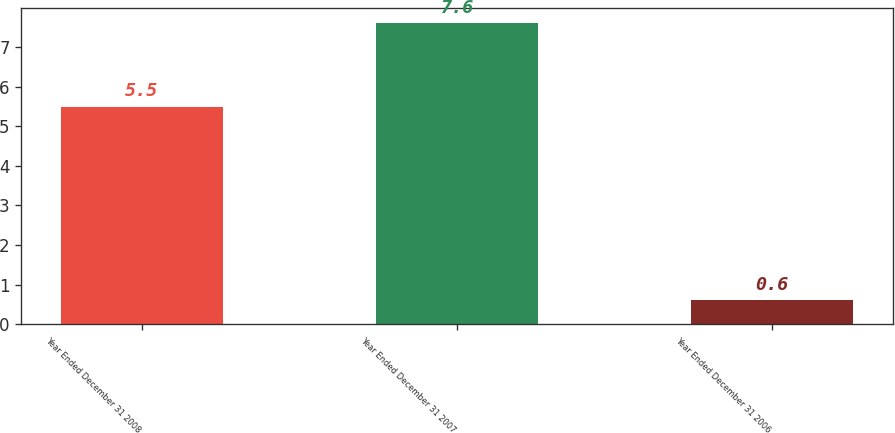<chart> <loc_0><loc_0><loc_500><loc_500><bar_chart><fcel>Year Ended December 31 2008<fcel>Year Ended December 31 2007<fcel>Year Ended December 31 2006<nl><fcel>5.5<fcel>7.6<fcel>0.6<nl></chart> 